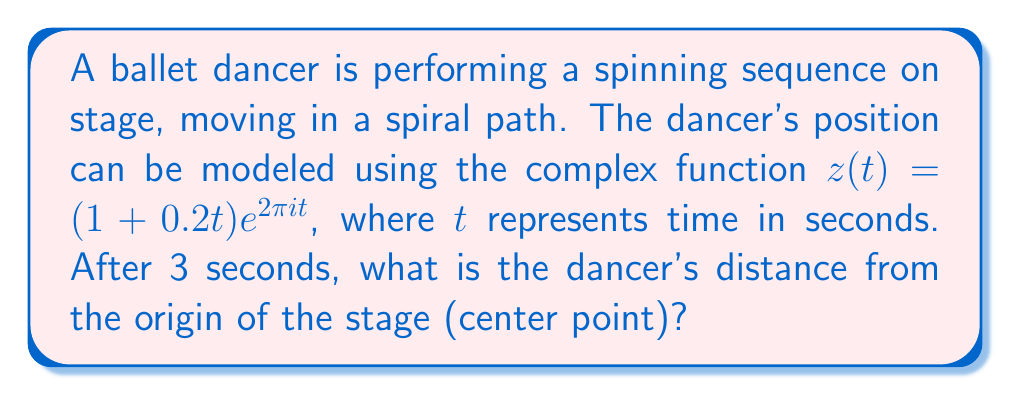Can you answer this question? Let's approach this step-by-step:

1) The given function $z(t) = (1 + 0.2t)e^{2\pi i t}$ is in the form of a complex exponential.

2) To find the distance from the origin, we need to calculate the magnitude of $z(3)$.

3) Let's substitute $t = 3$ into the function:

   $z(3) = (1 + 0.2(3))e^{2\pi i (3)}$

4) Simplify the real part:
   
   $z(3) = (1 + 0.6)e^{6\pi i} = 1.6e^{6\pi i}$

5) The magnitude of a complex number in the form $re^{i\theta}$ is simply $r$.

6) Therefore, the magnitude of $z(3)$ is:

   $|z(3)| = |1.6e^{6\pi i}| = 1.6$

7) This means the dancer is 1.6 units away from the center of the stage after 3 seconds.
Answer: 1.6 units 